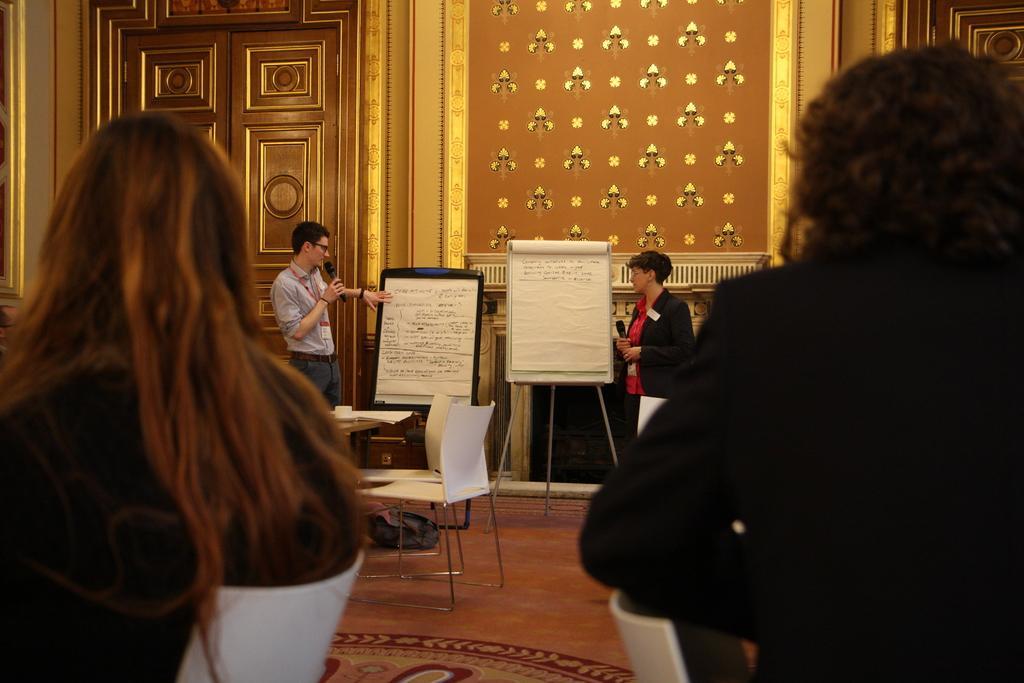Can you describe this image briefly? In this image I see a man and a woman who are near the boards and there are papers on it. I also see there are 2 people sitting on the chairs. In the background I see the wall and the door. 